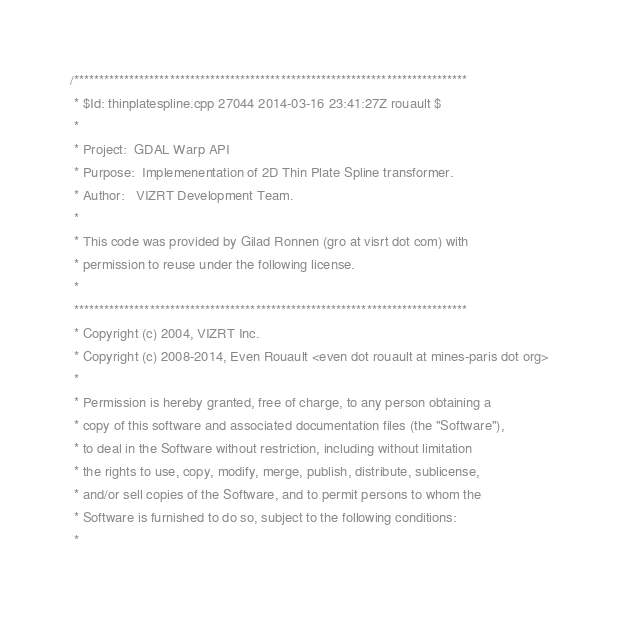<code> <loc_0><loc_0><loc_500><loc_500><_C++_>/******************************************************************************
 * $Id: thinplatespline.cpp 27044 2014-03-16 23:41:27Z rouault $
 *
 * Project:  GDAL Warp API
 * Purpose:  Implemenentation of 2D Thin Plate Spline transformer. 
 * Author:   VIZRT Development Team.
 *
 * This code was provided by Gilad Ronnen (gro at visrt dot com) with
 * permission to reuse under the following license.
 * 
 ******************************************************************************
 * Copyright (c) 2004, VIZRT Inc.
 * Copyright (c) 2008-2014, Even Rouault <even dot rouault at mines-paris dot org>
 *
 * Permission is hereby granted, free of charge, to any person obtaining a
 * copy of this software and associated documentation files (the "Software"),
 * to deal in the Software without restriction, including without limitation
 * the rights to use, copy, modify, merge, publish, distribute, sublicense,
 * and/or sell copies of the Software, and to permit persons to whom the
 * Software is furnished to do so, subject to the following conditions:
 *</code> 